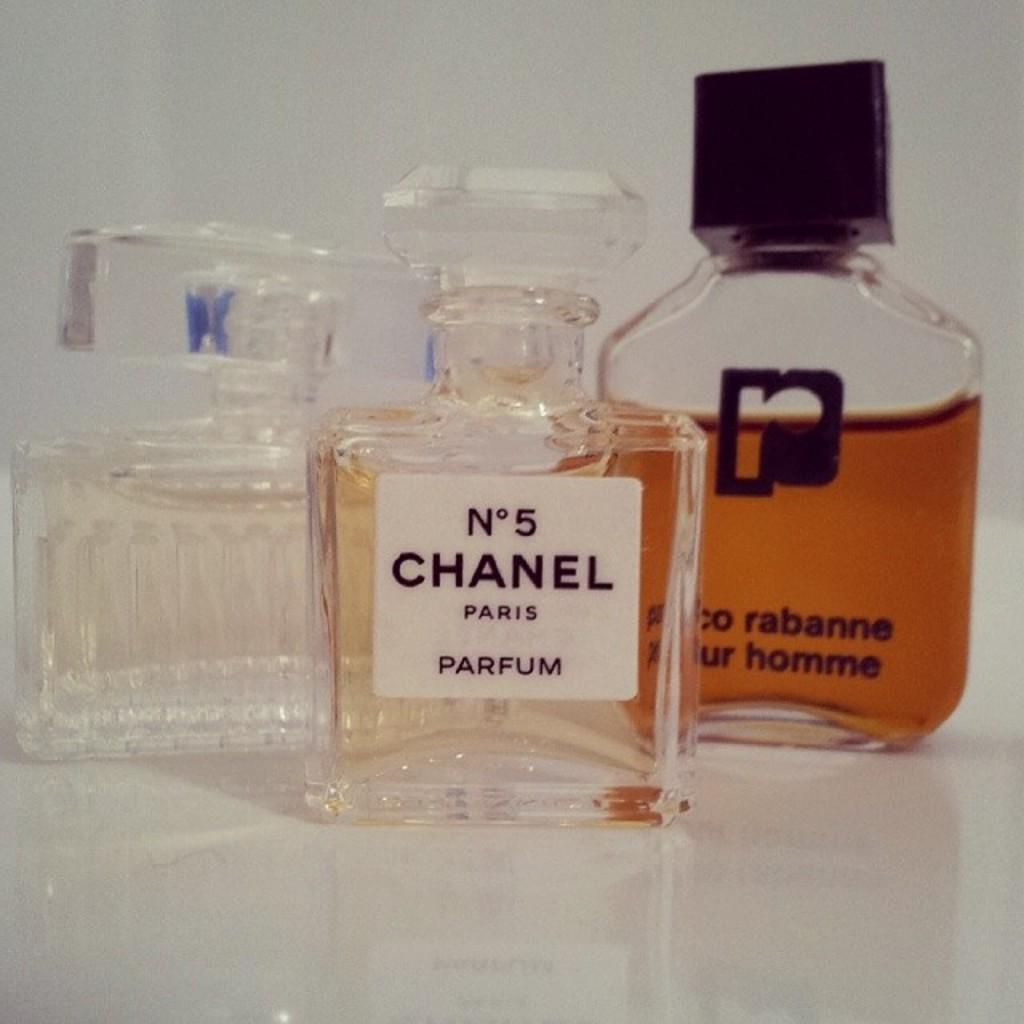<image>
Provide a brief description of the given image. A bottle of Chanel No 5 sits next to two other bottles of cologne 